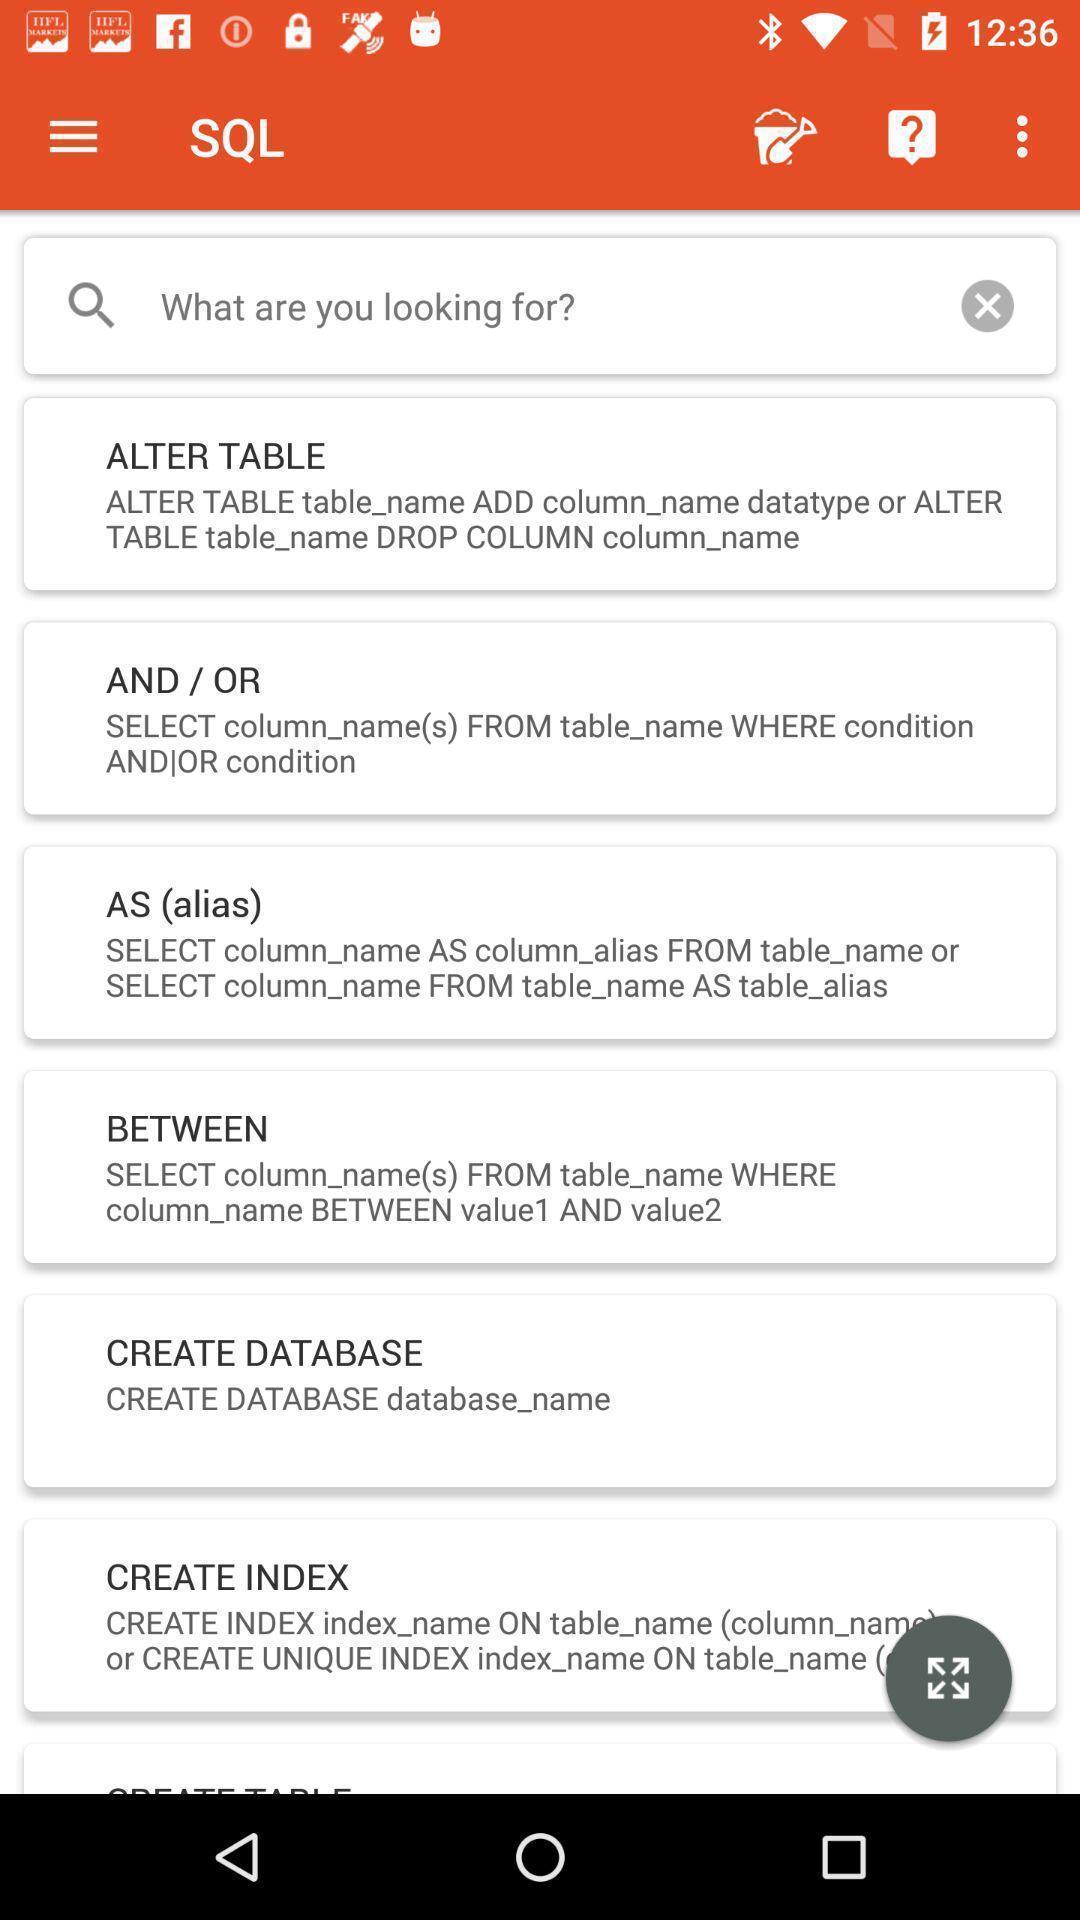Describe this image in words. Screen showing various commands of a database for learning app. 